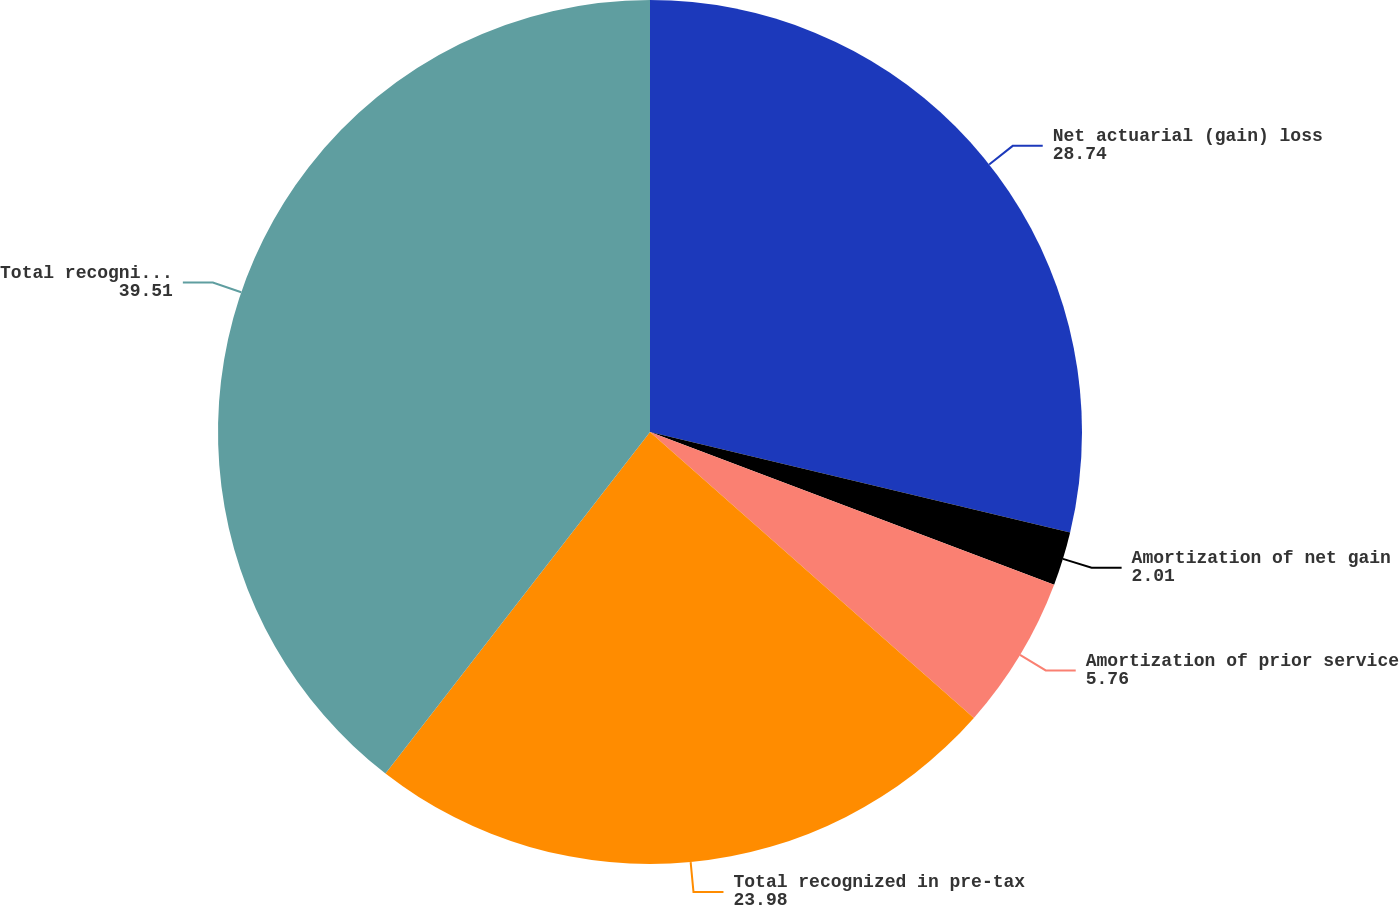Convert chart to OTSL. <chart><loc_0><loc_0><loc_500><loc_500><pie_chart><fcel>Net actuarial (gain) loss<fcel>Amortization of net gain<fcel>Amortization of prior service<fcel>Total recognized in pre-tax<fcel>Total recognized in net<nl><fcel>28.74%<fcel>2.01%<fcel>5.76%<fcel>23.98%<fcel>39.51%<nl></chart> 